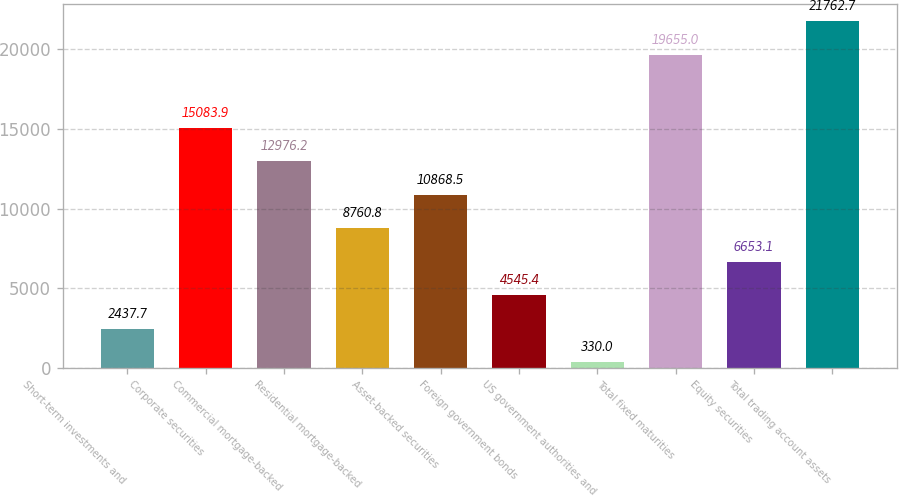Convert chart. <chart><loc_0><loc_0><loc_500><loc_500><bar_chart><fcel>Short-term investments and<fcel>Corporate securities<fcel>Commercial mortgage-backed<fcel>Residential mortgage-backed<fcel>Asset-backed securities<fcel>Foreign government bonds<fcel>US government authorities and<fcel>Total fixed maturities<fcel>Equity securities<fcel>Total trading account assets<nl><fcel>2437.7<fcel>15083.9<fcel>12976.2<fcel>8760.8<fcel>10868.5<fcel>4545.4<fcel>330<fcel>19655<fcel>6653.1<fcel>21762.7<nl></chart> 